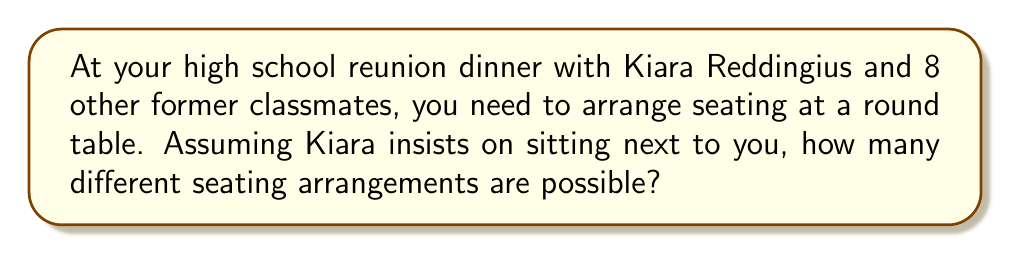Give your solution to this math problem. Let's approach this step-by-step:

1) First, consider that there are 10 people total (you, Kiara, and 8 others).

2) In a circular arrangement, rotations are considered the same arrangement. So we can fix your position and arrange the others.

3) Kiara must sit next to you, so we can consider you and Kiara as one unit.

4) Now we have 8 units to arrange: the you-Kiara unit and 7 other individuals.

5) The number of ways to arrange 8 units in a circle is $(8-1)! = 7!$

6) However, Kiara can sit on either your left or right. This doubles the number of arrangements.

7) Therefore, the total number of arrangements is:

   $$2 \times 7! = 2 \times 5040 = 10080$$
Answer: 10080 